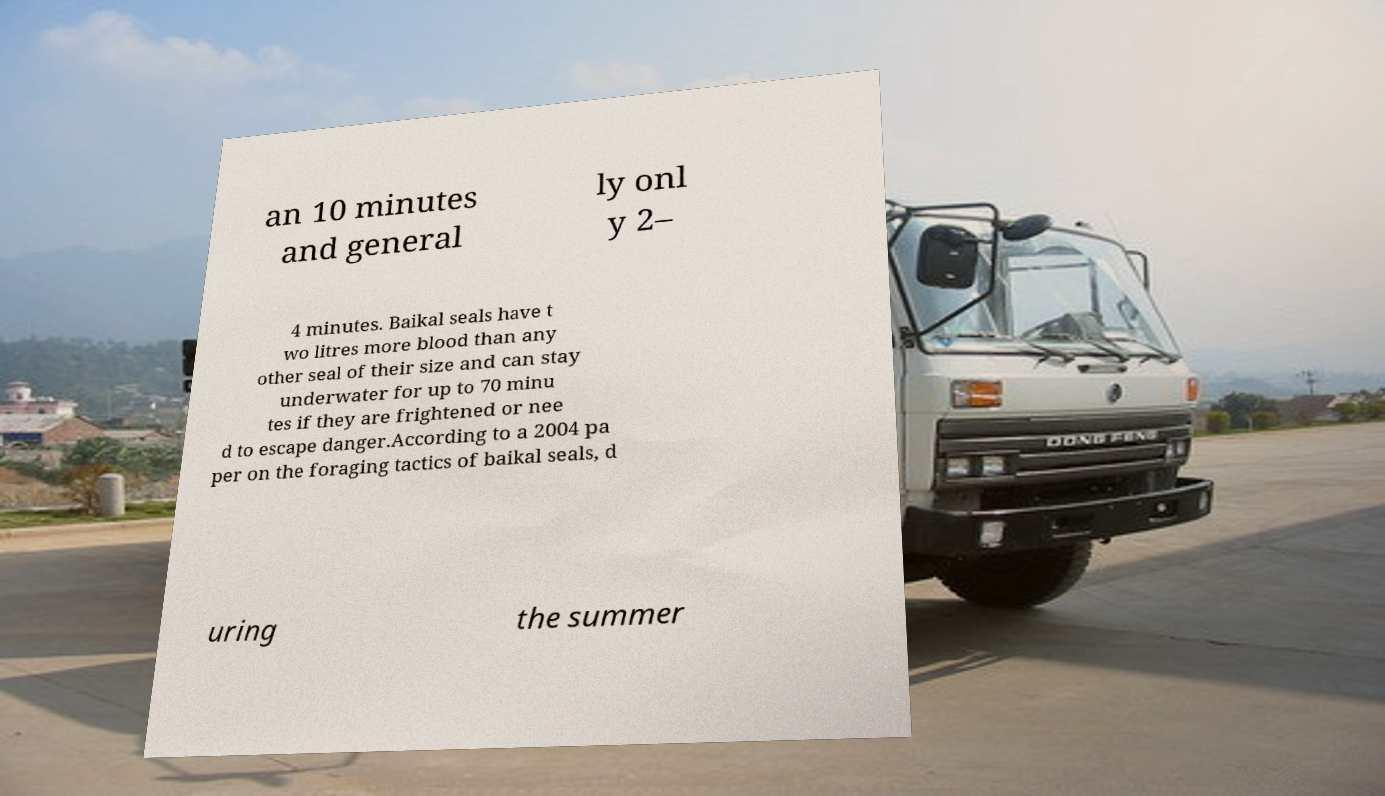For documentation purposes, I need the text within this image transcribed. Could you provide that? an 10 minutes and general ly onl y 2– 4 minutes. Baikal seals have t wo litres more blood than any other seal of their size and can stay underwater for up to 70 minu tes if they are frightened or nee d to escape danger.According to a 2004 pa per on the foraging tactics of baikal seals, d uring the summer 